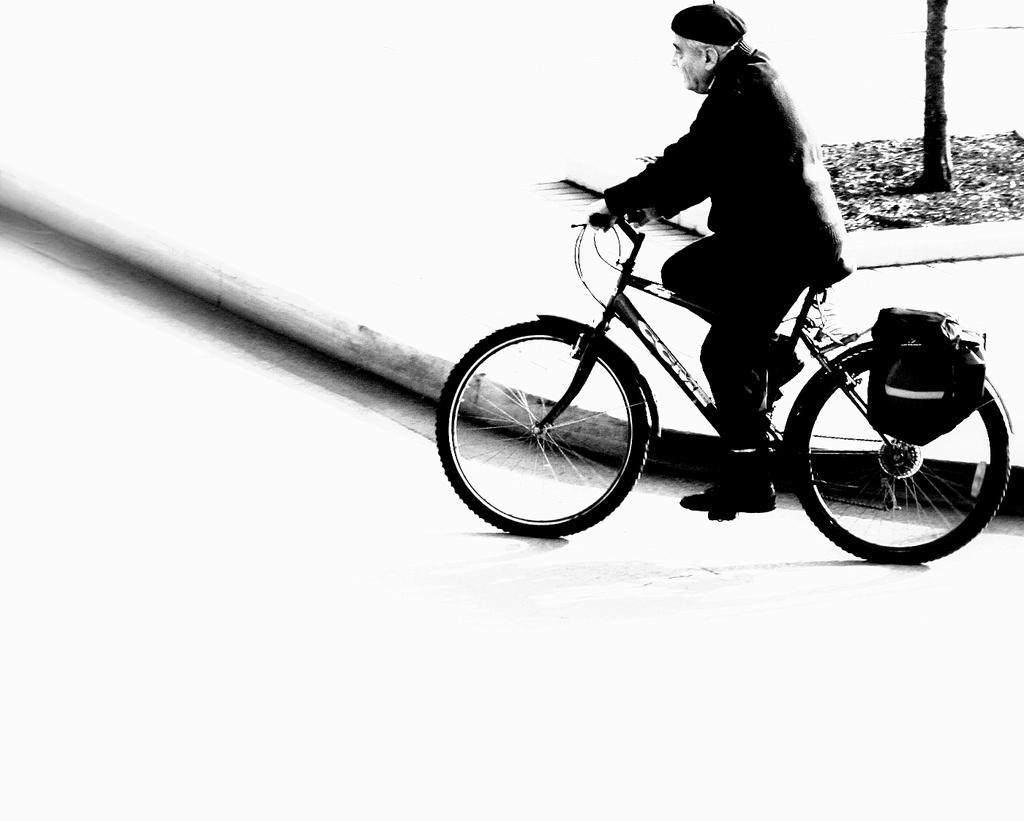Could you give a brief overview of what you see in this image? In the image we can see one man riding cycle. In the background there is a tree. 